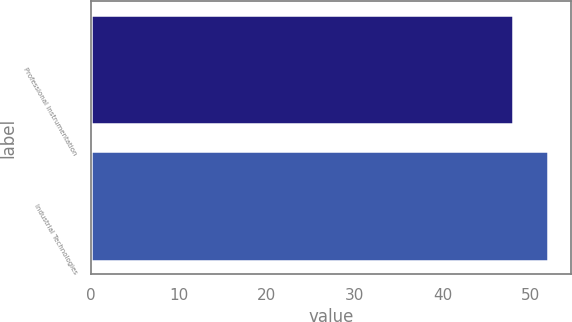Convert chart to OTSL. <chart><loc_0><loc_0><loc_500><loc_500><bar_chart><fcel>Professional Instrumentation<fcel>Industrial Technologies<nl><fcel>48<fcel>52<nl></chart> 